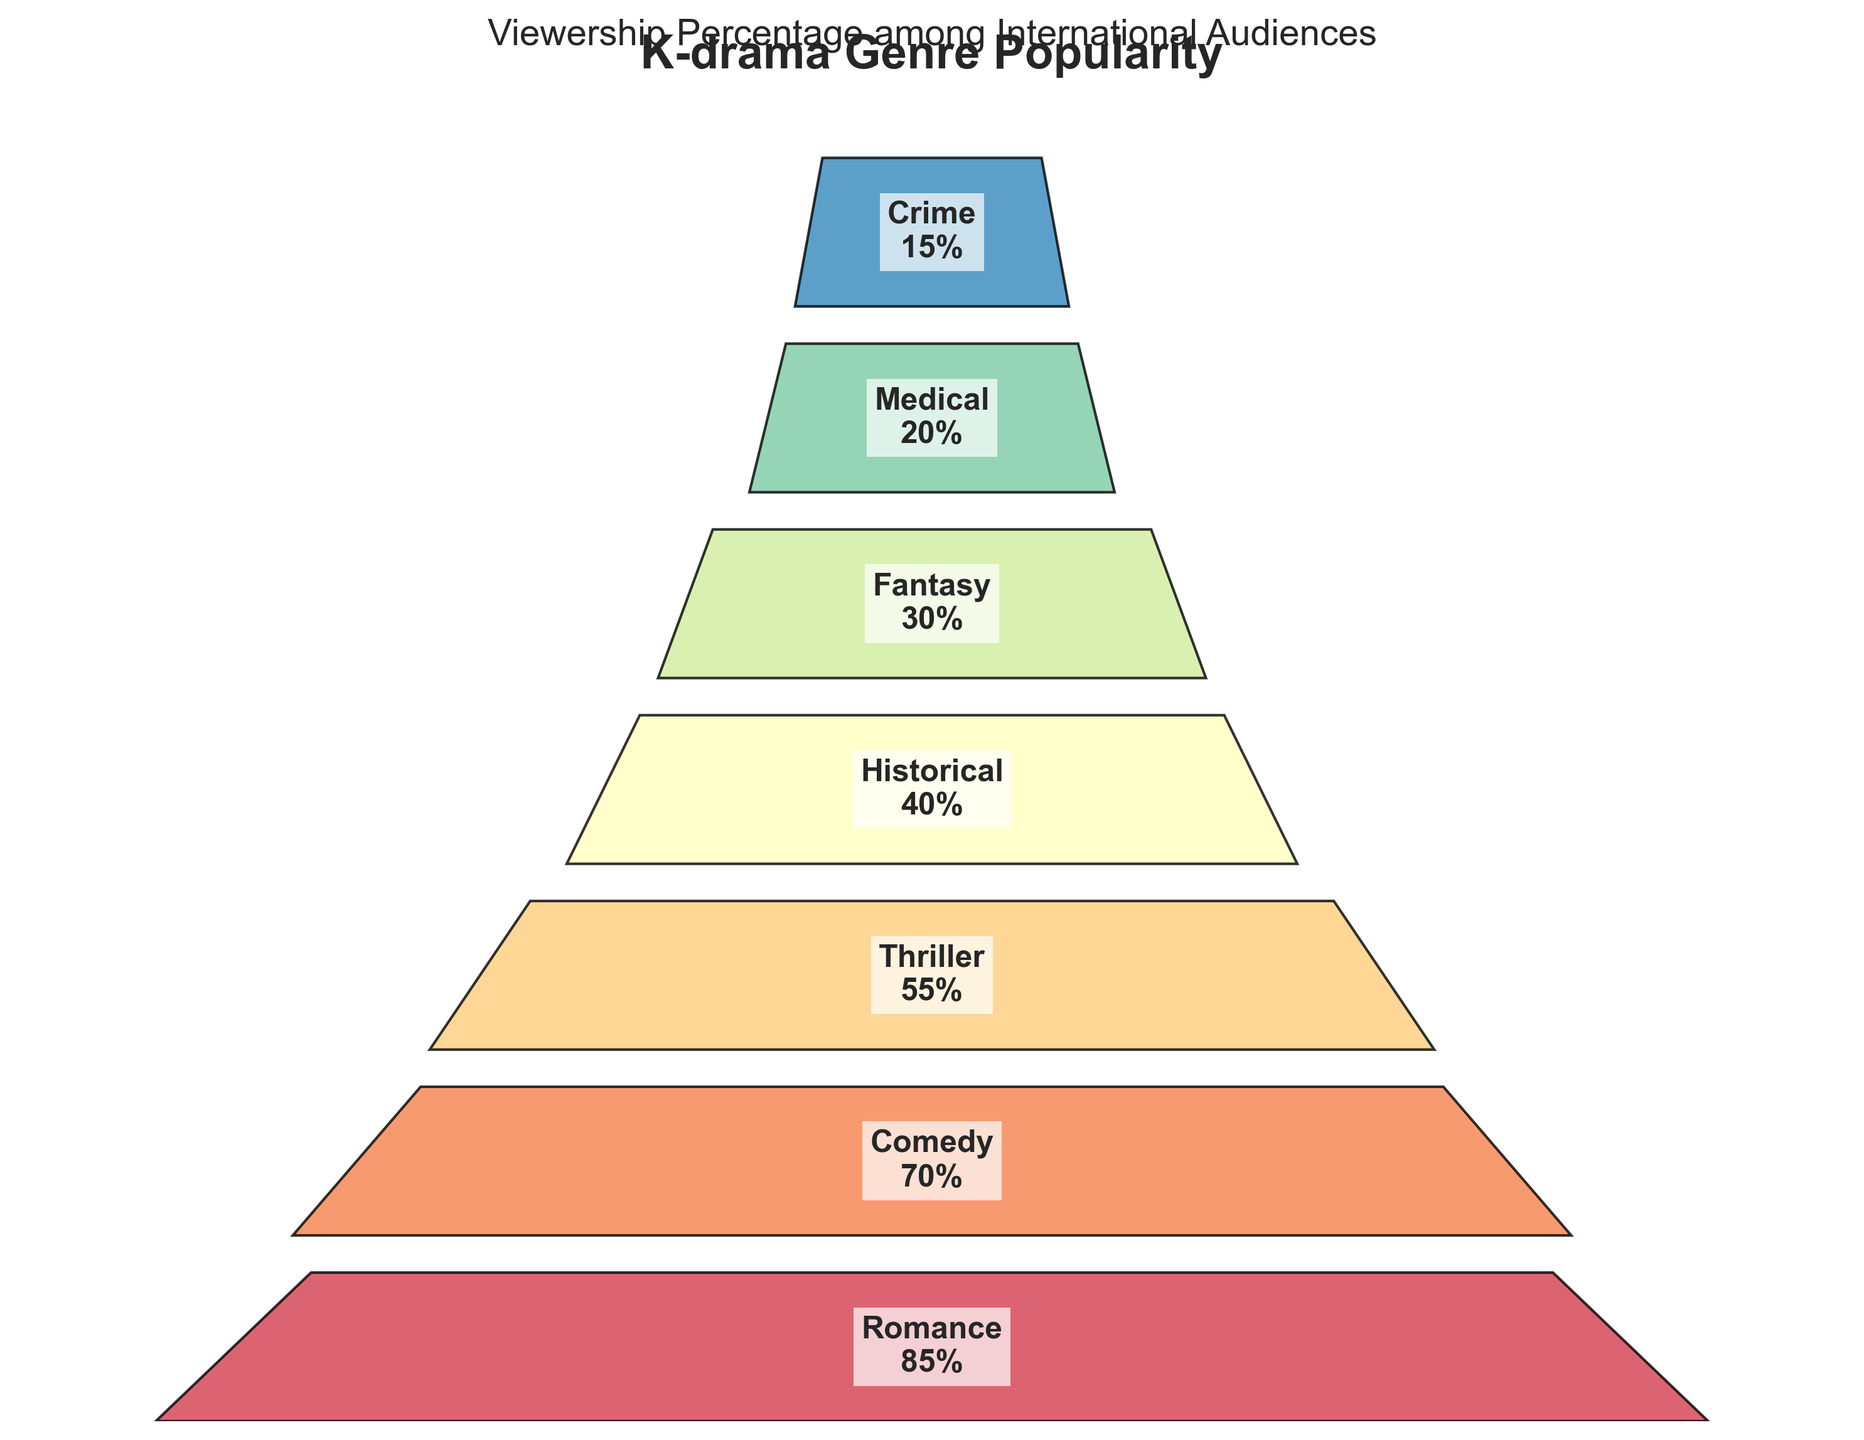what is the most popular K-drama genre according to the funnel chart? The funnel chart ranks genres from the widest to the narrowest section. The genre at the widest section at the top is the most popular.
Answer: Romance what percentage of viewership does the Fantasy genre have? Locate the Fantasy genre in the funnel chart and read the corresponding percentage displayed.
Answer: 30% which genre ranks third in popularity? Count from the widest section to the third section from the top and read the genre name.
Answer: Thriller which genre has a higher viewership percentage, Medical or Comedy? Identify the positions of Medical and Comedy in the funnel chart and compare their percentages.
Answer: Comedy what is the total viewership percentage for Romance, Historical, and Crime genres combined? Add the viewership percentages of Romance (85), Historical (40), and Crime (15). 85 + 40 + 15 = 140
Answer: 140 which genre has the second-lowest viewership percentage? Locate the second narrowest section from the bottom on the funnel chart and read the genre name.
Answer: Medical what is the difference in viewership percentage between the most and least popular genres? Subtract the viewership percentage of the least popular genre (Crime, 15) from the most popular genre (Romance, 85). 85 - 15 = 70
Answer: 70 how many genres have a viewership percentage of 50% or higher? Count the number of genres from the top section until a percentage below 50% is reached (Romance, Comedy, Thriller).
Answer: 3 if the least popular genre (Crime) increased its viewership percentage by 10%, what would be its new percentage? Add 10% to the current viewership percentage of Crime (15). 15 + 10 = 25
Answer: 25 what is the average viewership percentage of the genres shown in the funnel chart? Add all the percentages and divide by the number of genres. (85 + 70 + 55 + 40 + 30 + 20 + 15) / 7 = 315 / 7 = 45
Answer: 45 